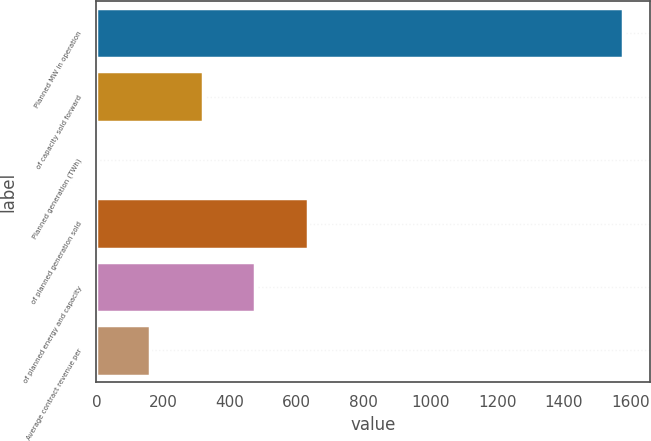Convert chart to OTSL. <chart><loc_0><loc_0><loc_500><loc_500><bar_chart><fcel>Planned MW in operation<fcel>of capacity sold forward<fcel>Planned generation (TWh)<fcel>of planned generation sold<fcel>of planned energy and capacity<fcel>Average contract revenue per<nl><fcel>1578<fcel>318<fcel>3<fcel>633<fcel>475.5<fcel>160.5<nl></chart> 